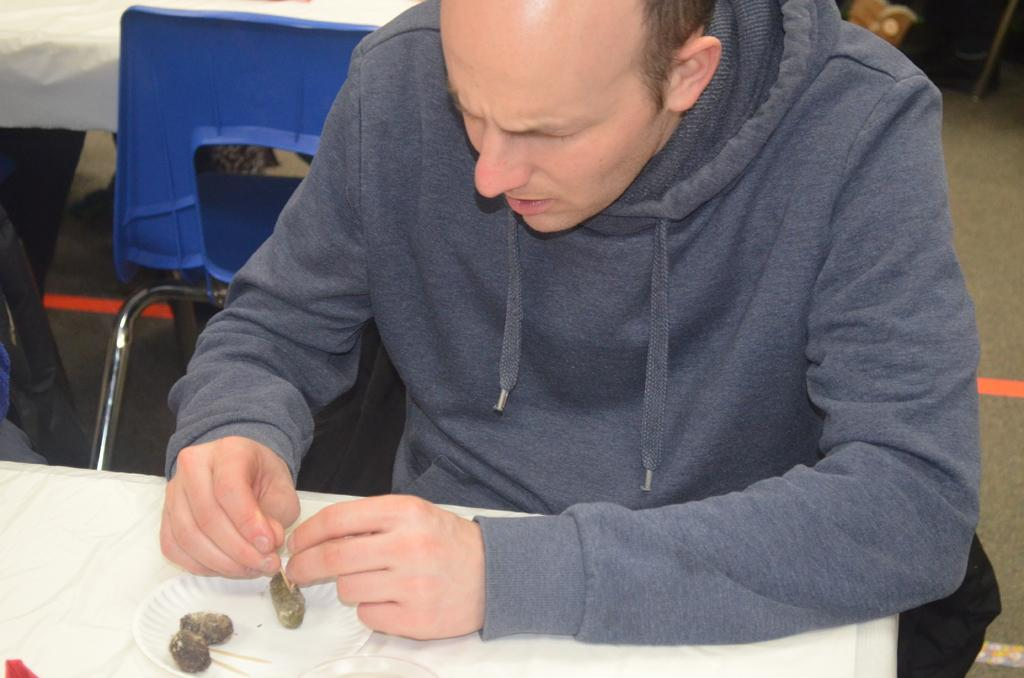Who is present in the image? There is a man in the picture. What is the man doing in the image? The man is sitting in front of a table and eating food. Can you describe the chair behind the man? There is a blue chair behind the man. What type of mine is visible in the background of the image? There is no mine present in the image; it features a man sitting at a table and eating food. What kind of doll is sitting on the table next to the man? There is no doll present on the table or in the image. 